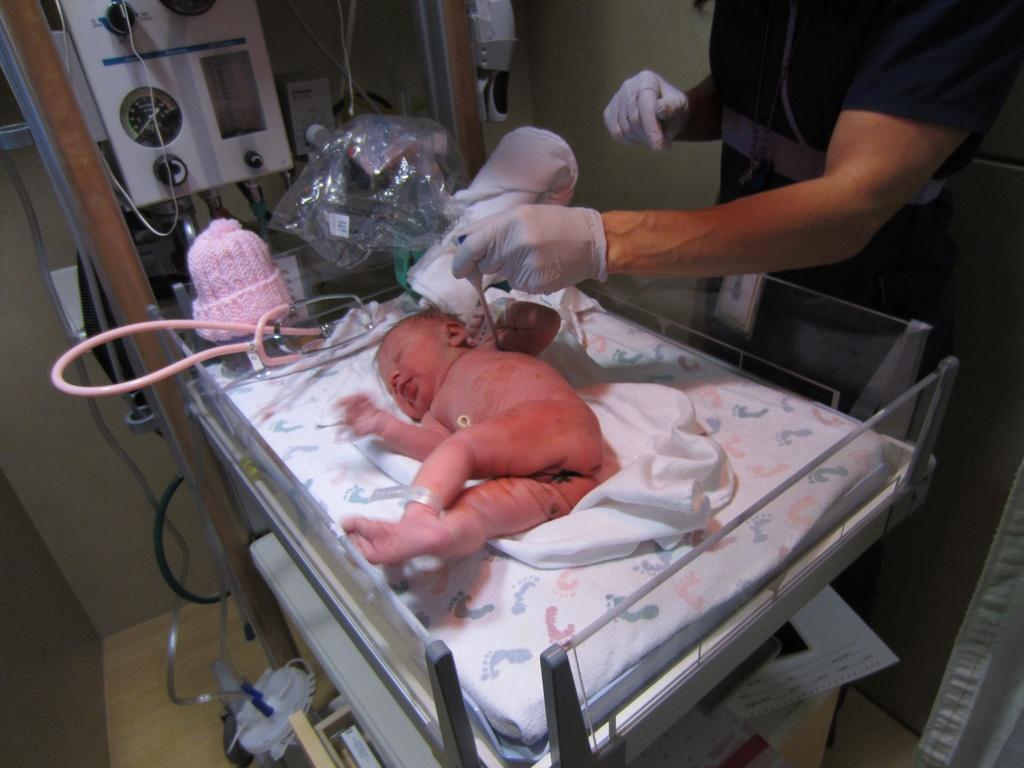What is on the bed in the image? There is a baby on the bed in the image. Who is present on the right side of the bed? There is a person on the right side of the bed. What is the person wearing on their hands? The person is wearing hand gloves. How far is the baby from the skateboard in the image? There is no skateboard present in the image, so it is not possible to determine the distance between the baby and a skateboard. 